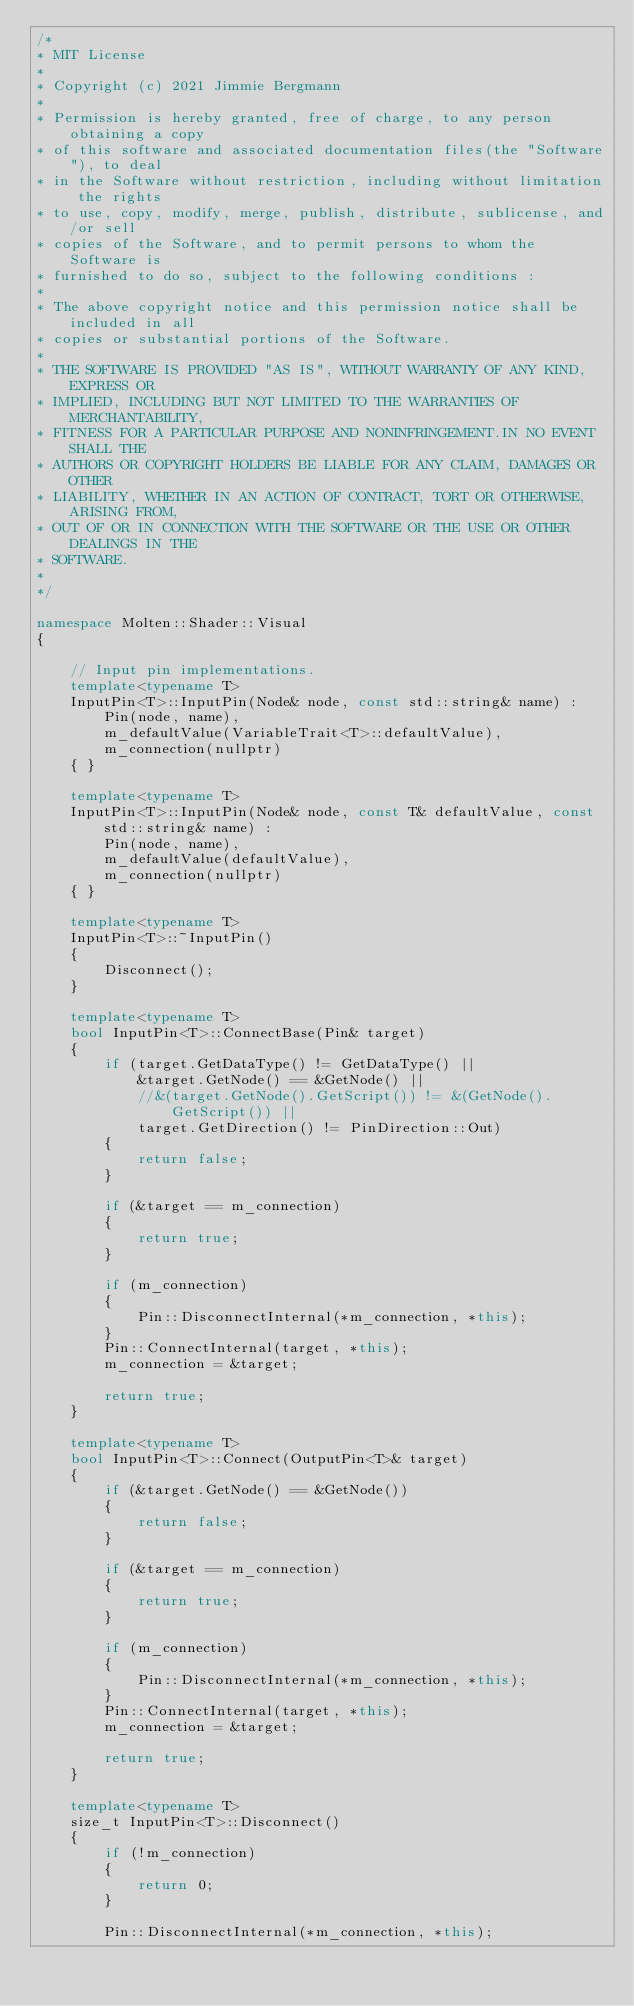<code> <loc_0><loc_0><loc_500><loc_500><_C++_>/*
* MIT License
*
* Copyright (c) 2021 Jimmie Bergmann
*
* Permission is hereby granted, free of charge, to any person obtaining a copy
* of this software and associated documentation files(the "Software"), to deal
* in the Software without restriction, including without limitation the rights
* to use, copy, modify, merge, publish, distribute, sublicense, and/or sell
* copies of the Software, and to permit persons to whom the Software is
* furnished to do so, subject to the following conditions :
*
* The above copyright notice and this permission notice shall be included in all
* copies or substantial portions of the Software.
*
* THE SOFTWARE IS PROVIDED "AS IS", WITHOUT WARRANTY OF ANY KIND, EXPRESS OR
* IMPLIED, INCLUDING BUT NOT LIMITED TO THE WARRANTIES OF MERCHANTABILITY,
* FITNESS FOR A PARTICULAR PURPOSE AND NONINFRINGEMENT.IN NO EVENT SHALL THE
* AUTHORS OR COPYRIGHT HOLDERS BE LIABLE FOR ANY CLAIM, DAMAGES OR OTHER
* LIABILITY, WHETHER IN AN ACTION OF CONTRACT, TORT OR OTHERWISE, ARISING FROM,
* OUT OF OR IN CONNECTION WITH THE SOFTWARE OR THE USE OR OTHER DEALINGS IN THE
* SOFTWARE.
*
*/

namespace Molten::Shader::Visual
{

    // Input pin implementations.
    template<typename T>
    InputPin<T>::InputPin(Node& node, const std::string& name) :
        Pin(node, name),
        m_defaultValue(VariableTrait<T>::defaultValue),
        m_connection(nullptr)
    { }

    template<typename T>
    InputPin<T>::InputPin(Node& node, const T& defaultValue, const std::string& name) :
        Pin(node, name),
        m_defaultValue(defaultValue),
        m_connection(nullptr)
    { }

    template<typename T>
    InputPin<T>::~InputPin()
    {
        Disconnect();
    }

    template<typename T>
    bool InputPin<T>::ConnectBase(Pin& target)
    {
        if (target.GetDataType() != GetDataType() ||
            &target.GetNode() == &GetNode() ||
            //&(target.GetNode().GetScript()) != &(GetNode().GetScript()) ||
            target.GetDirection() != PinDirection::Out)
        {
            return false;
        }

        if (&target == m_connection)
        {
            return true;
        }

        if (m_connection)
        {
            Pin::DisconnectInternal(*m_connection, *this);
        }     
        Pin::ConnectInternal(target, *this);
        m_connection = &target;

        return true;
    }

    template<typename T>
    bool InputPin<T>::Connect(OutputPin<T>& target)
    {
        if (&target.GetNode() == &GetNode())
        {
            return false;
        }

        if (&target == m_connection)
        {
            return true;
        }

        if (m_connection)
        {
            Pin::DisconnectInternal(*m_connection, *this);
        }
        Pin::ConnectInternal(target, *this);
        m_connection = &target;

        return true;
    }

    template<typename T>
    size_t InputPin<T>::Disconnect()
    {
        if (!m_connection)
        {
            return 0;
        }

        Pin::DisconnectInternal(*m_connection, *this);</code> 